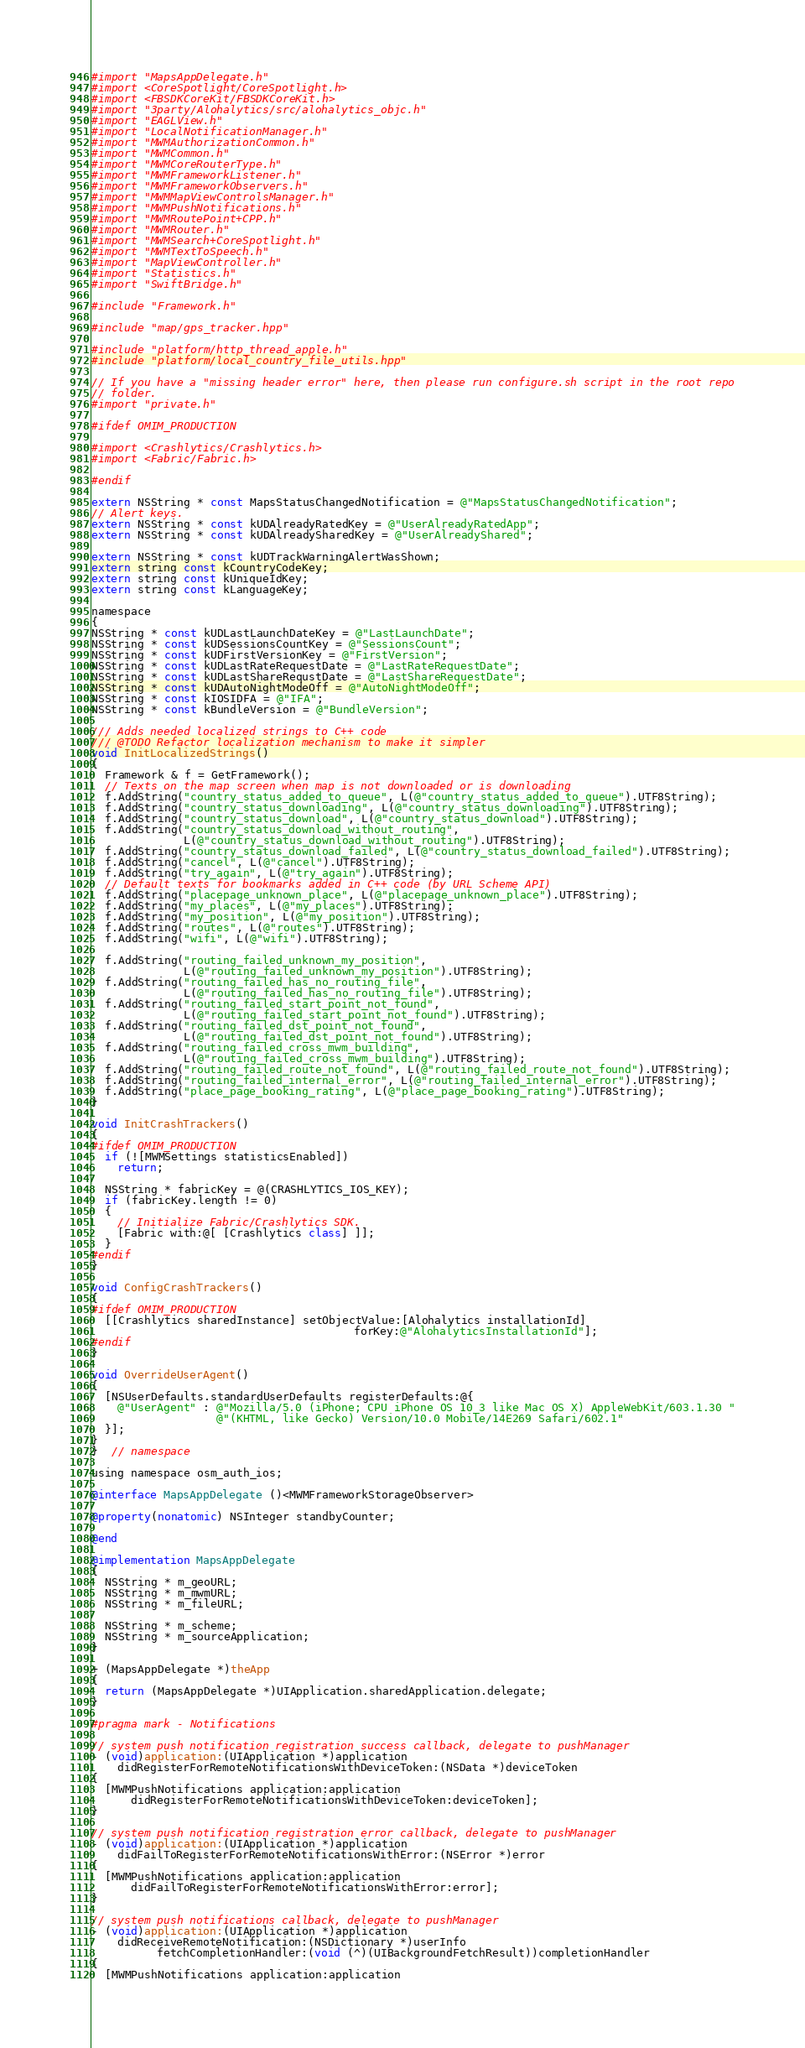<code> <loc_0><loc_0><loc_500><loc_500><_ObjectiveC_>#import "MapsAppDelegate.h"
#import <CoreSpotlight/CoreSpotlight.h>
#import <FBSDKCoreKit/FBSDKCoreKit.h>
#import "3party/Alohalytics/src/alohalytics_objc.h"
#import "EAGLView.h"
#import "LocalNotificationManager.h"
#import "MWMAuthorizationCommon.h"
#import "MWMCommon.h"
#import "MWMCoreRouterType.h"
#import "MWMFrameworkListener.h"
#import "MWMFrameworkObservers.h"
#import "MWMMapViewControlsManager.h"
#import "MWMPushNotifications.h"
#import "MWMRoutePoint+CPP.h"
#import "MWMRouter.h"
#import "MWMSearch+CoreSpotlight.h"
#import "MWMTextToSpeech.h"
#import "MapViewController.h"
#import "Statistics.h"
#import "SwiftBridge.h"

#include "Framework.h"

#include "map/gps_tracker.hpp"

#include "platform/http_thread_apple.h"
#include "platform/local_country_file_utils.hpp"

// If you have a "missing header error" here, then please run configure.sh script in the root repo
// folder.
#import "private.h"

#ifdef OMIM_PRODUCTION

#import <Crashlytics/Crashlytics.h>
#import <Fabric/Fabric.h>

#endif

extern NSString * const MapsStatusChangedNotification = @"MapsStatusChangedNotification";
// Alert keys.
extern NSString * const kUDAlreadyRatedKey = @"UserAlreadyRatedApp";
extern NSString * const kUDAlreadySharedKey = @"UserAlreadyShared";

extern NSString * const kUDTrackWarningAlertWasShown;
extern string const kCountryCodeKey;
extern string const kUniqueIdKey;
extern string const kLanguageKey;

namespace
{
NSString * const kUDLastLaunchDateKey = @"LastLaunchDate";
NSString * const kUDSessionsCountKey = @"SessionsCount";
NSString * const kUDFirstVersionKey = @"FirstVersion";
NSString * const kUDLastRateRequestDate = @"LastRateRequestDate";
NSString * const kUDLastShareRequstDate = @"LastShareRequestDate";
NSString * const kUDAutoNightModeOff = @"AutoNightModeOff";
NSString * const kIOSIDFA = @"IFA";
NSString * const kBundleVersion = @"BundleVersion";

/// Adds needed localized strings to C++ code
/// @TODO Refactor localization mechanism to make it simpler
void InitLocalizedStrings()
{
  Framework & f = GetFramework();
  // Texts on the map screen when map is not downloaded or is downloading
  f.AddString("country_status_added_to_queue", L(@"country_status_added_to_queue").UTF8String);
  f.AddString("country_status_downloading", L(@"country_status_downloading").UTF8String);
  f.AddString("country_status_download", L(@"country_status_download").UTF8String);
  f.AddString("country_status_download_without_routing",
              L(@"country_status_download_without_routing").UTF8String);
  f.AddString("country_status_download_failed", L(@"country_status_download_failed").UTF8String);
  f.AddString("cancel", L(@"cancel").UTF8String);
  f.AddString("try_again", L(@"try_again").UTF8String);
  // Default texts for bookmarks added in C++ code (by URL Scheme API)
  f.AddString("placepage_unknown_place", L(@"placepage_unknown_place").UTF8String);
  f.AddString("my_places", L(@"my_places").UTF8String);
  f.AddString("my_position", L(@"my_position").UTF8String);
  f.AddString("routes", L(@"routes").UTF8String);
  f.AddString("wifi", L(@"wifi").UTF8String);

  f.AddString("routing_failed_unknown_my_position",
              L(@"routing_failed_unknown_my_position").UTF8String);
  f.AddString("routing_failed_has_no_routing_file",
              L(@"routing_failed_has_no_routing_file").UTF8String);
  f.AddString("routing_failed_start_point_not_found",
              L(@"routing_failed_start_point_not_found").UTF8String);
  f.AddString("routing_failed_dst_point_not_found",
              L(@"routing_failed_dst_point_not_found").UTF8String);
  f.AddString("routing_failed_cross_mwm_building",
              L(@"routing_failed_cross_mwm_building").UTF8String);
  f.AddString("routing_failed_route_not_found", L(@"routing_failed_route_not_found").UTF8String);
  f.AddString("routing_failed_internal_error", L(@"routing_failed_internal_error").UTF8String);
  f.AddString("place_page_booking_rating", L(@"place_page_booking_rating").UTF8String);
}

void InitCrashTrackers()
{
#ifdef OMIM_PRODUCTION
  if (![MWMSettings statisticsEnabled])
    return;

  NSString * fabricKey = @(CRASHLYTICS_IOS_KEY);
  if (fabricKey.length != 0)
  {
    // Initialize Fabric/Crashlytics SDK.
    [Fabric with:@[ [Crashlytics class] ]];
  }
#endif
}

void ConfigCrashTrackers()
{
#ifdef OMIM_PRODUCTION
  [[Crashlytics sharedInstance] setObjectValue:[Alohalytics installationId]
                                        forKey:@"AlohalyticsInstallationId"];
#endif
}

void OverrideUserAgent()
{
  [NSUserDefaults.standardUserDefaults registerDefaults:@{
    @"UserAgent" : @"Mozilla/5.0 (iPhone; CPU iPhone OS 10_3 like Mac OS X) AppleWebKit/603.1.30 "
                   @"(KHTML, like Gecko) Version/10.0 Mobile/14E269 Safari/602.1"
  }];
}
}  // namespace

using namespace osm_auth_ios;

@interface MapsAppDelegate ()<MWMFrameworkStorageObserver>

@property(nonatomic) NSInteger standbyCounter;

@end

@implementation MapsAppDelegate
{
  NSString * m_geoURL;
  NSString * m_mwmURL;
  NSString * m_fileURL;

  NSString * m_scheme;
  NSString * m_sourceApplication;
}

+ (MapsAppDelegate *)theApp
{
  return (MapsAppDelegate *)UIApplication.sharedApplication.delegate;
}

#pragma mark - Notifications

// system push notification registration success callback, delegate to pushManager
- (void)application:(UIApplication *)application
    didRegisterForRemoteNotificationsWithDeviceToken:(NSData *)deviceToken
{
  [MWMPushNotifications application:application
      didRegisterForRemoteNotificationsWithDeviceToken:deviceToken];
}

// system push notification registration error callback, delegate to pushManager
- (void)application:(UIApplication *)application
    didFailToRegisterForRemoteNotificationsWithError:(NSError *)error
{
  [MWMPushNotifications application:application
      didFailToRegisterForRemoteNotificationsWithError:error];
}

// system push notifications callback, delegate to pushManager
- (void)application:(UIApplication *)application
    didReceiveRemoteNotification:(NSDictionary *)userInfo
          fetchCompletionHandler:(void (^)(UIBackgroundFetchResult))completionHandler
{
  [MWMPushNotifications application:application</code> 